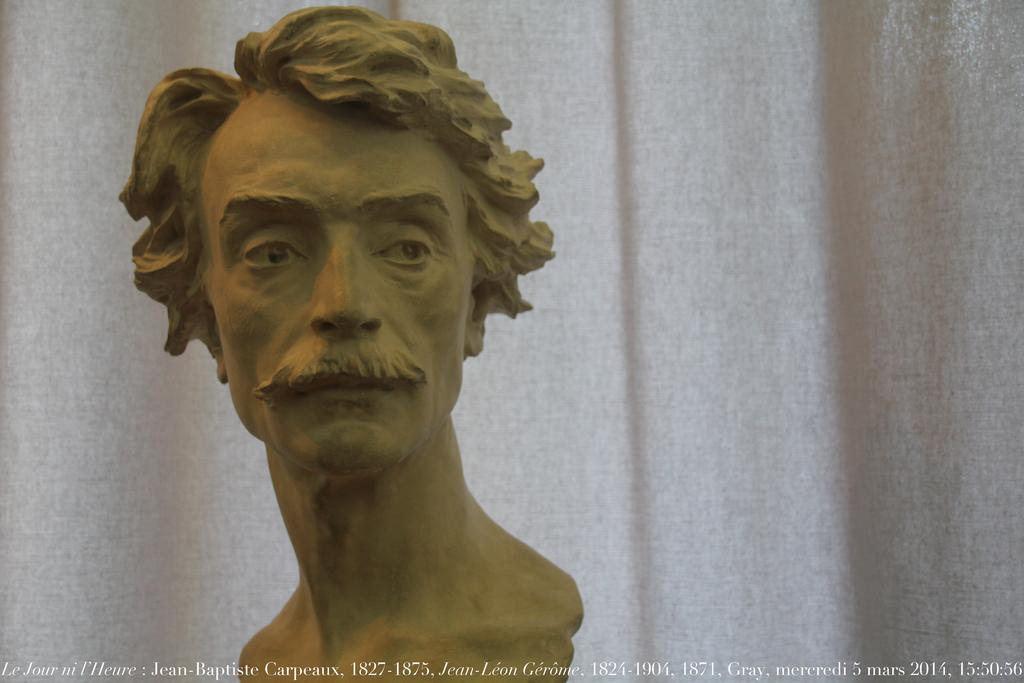What is the main subject of the image? The main subject of the image is a statue of a man. What can be seen behind the statue? There is a white color curtain behind the statue. What type of hope can be seen in the image? There is no reference to hope in the image; it features a statue of a man with a white color curtain behind it. What is the arm of the statue doing in the image? The image does not show the statue's arm or any specific action it might be performing. 